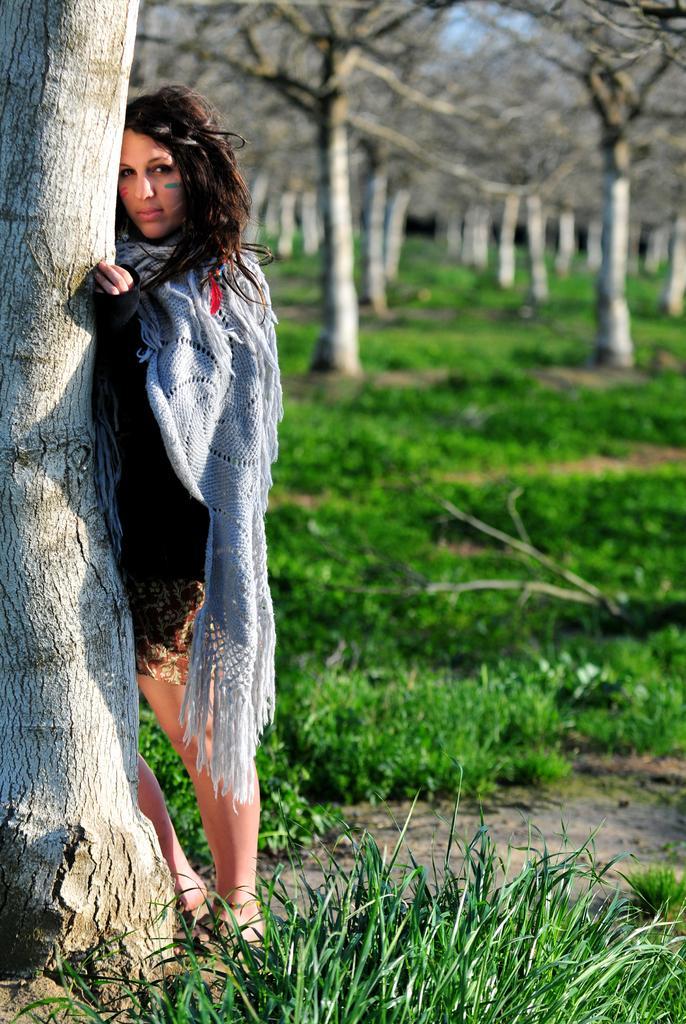Describe this image in one or two sentences. In this image I can see a person standing wearing black and gray color dress, at the back I can see dried trees and grass is in green color, and the sky is in blue color. 